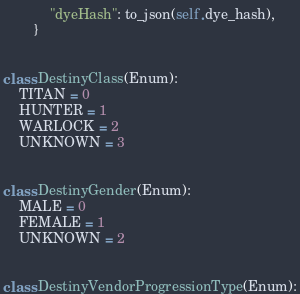Convert code to text. <code><loc_0><loc_0><loc_500><loc_500><_Python_>            "dyeHash": to_json(self.dye_hash),
        }


class DestinyClass(Enum):
    TITAN = 0
    HUNTER = 1
    WARLOCK = 2
    UNKNOWN = 3


class DestinyGender(Enum):
    MALE = 0
    FEMALE = 1
    UNKNOWN = 2


class DestinyVendorProgressionType(Enum):</code> 